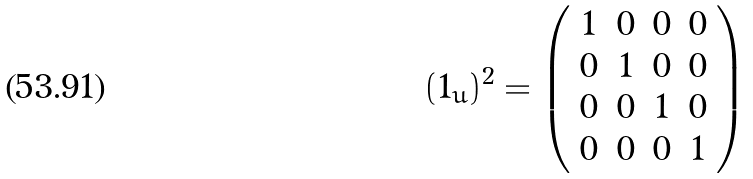Convert formula to latex. <formula><loc_0><loc_0><loc_500><loc_500>( 1 _ { u } ) ^ { 2 } = \left ( \begin{array} { c c c c } 1 & 0 & 0 & 0 \\ 0 & 1 & 0 & 0 \\ 0 & 0 & 1 & 0 \\ 0 & 0 & 0 & 1 \\ \end{array} \right )</formula> 